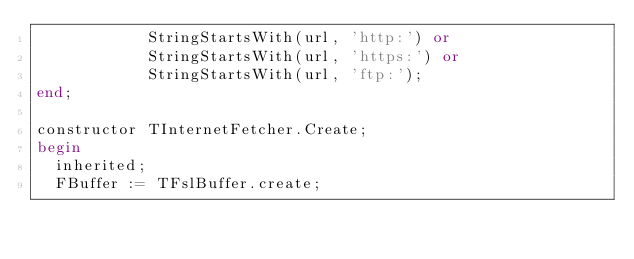Convert code to text. <code><loc_0><loc_0><loc_500><loc_500><_Pascal_>            StringStartsWith(url, 'http:') or
            StringStartsWith(url, 'https:') or
            StringStartsWith(url, 'ftp:');
end;

constructor TInternetFetcher.Create;
begin
  inherited;
  FBuffer := TFslBuffer.create;</code> 